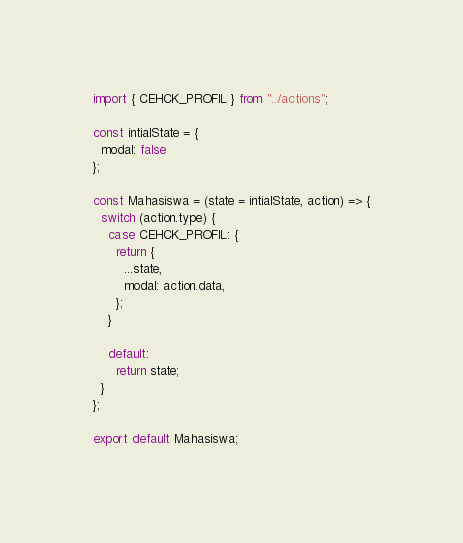<code> <loc_0><loc_0><loc_500><loc_500><_JavaScript_>import { CEHCK_PROFIL } from "../actions";

const intialState = {
  modal: false
};

const Mahasiswa = (state = intialState, action) => {
  switch (action.type) {
    case CEHCK_PROFIL: {
      return {
        ...state,
        modal: action.data,
      };
    }

    default:
      return state;
  }
};

export default Mahasiswa;
</code> 